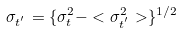<formula> <loc_0><loc_0><loc_500><loc_500>\sigma _ { t ^ { ^ { \prime } } } = \{ \sigma _ { t } ^ { 2 } - < \sigma _ { t ^ { ^ { \prime } } } ^ { 2 } > \} ^ { 1 / 2 }</formula> 